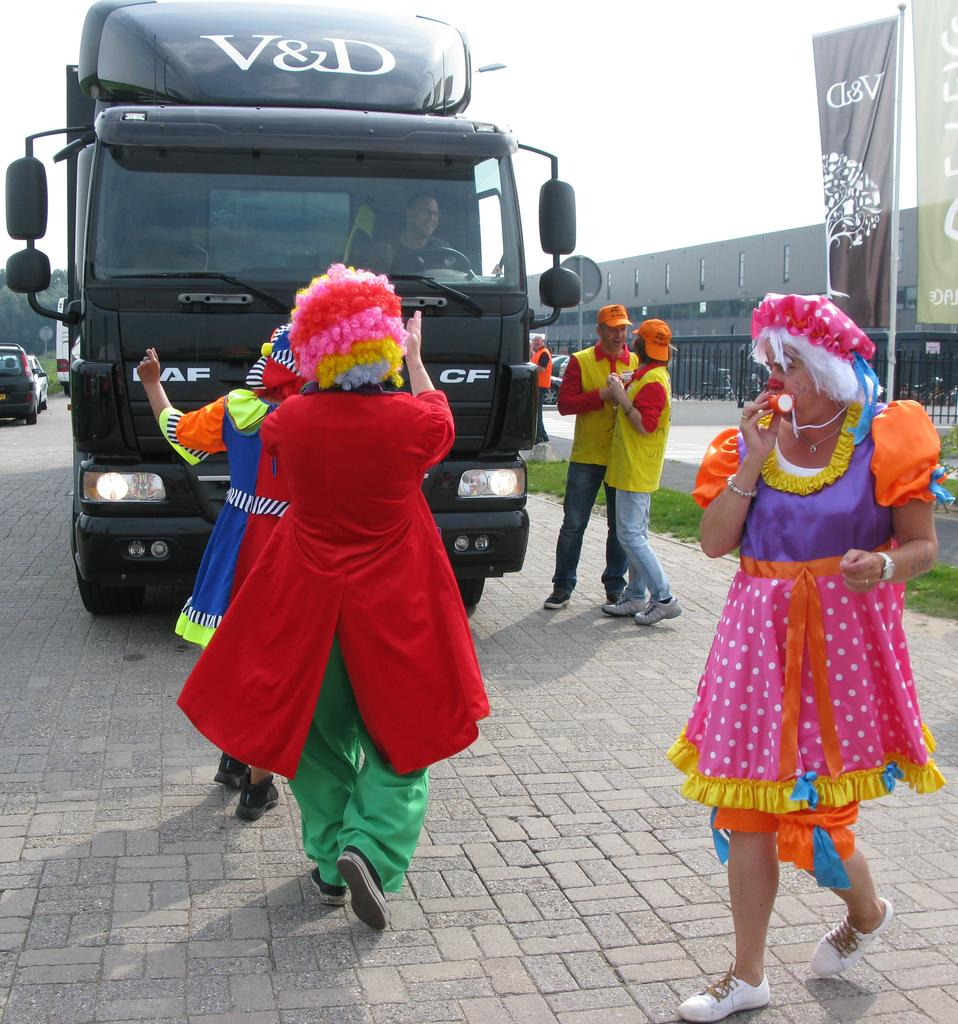What can be seen in the image? There are people standing in the image, along with a truck. What else is visible in the background of the image? Cars are visible in the background of the image. What is visible at the top of the image? The sky is visible at the top of the image. What type of window is visible in the image? There is no window present in the image. What kind of drug can be seen being used by the people in the image? There is no drug use depicted in the image; it features people standing near a truck and cars in the background. 